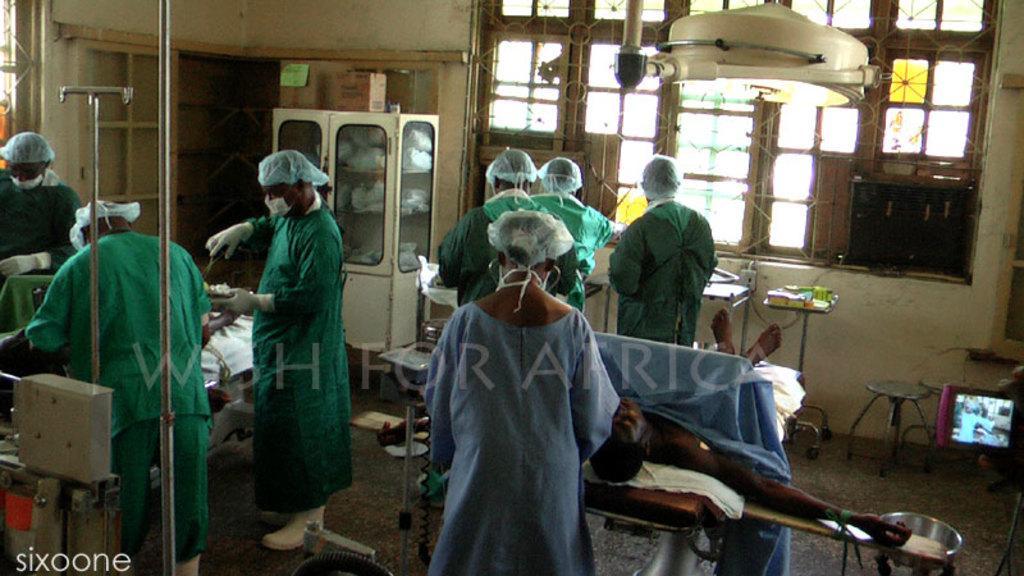Could you give a brief overview of what you see in this image? In this image I can see people are standing among them two people are lying on the bed. In the background I can cupboard, windows, tables and some other objects. Here I can see a watermark. 